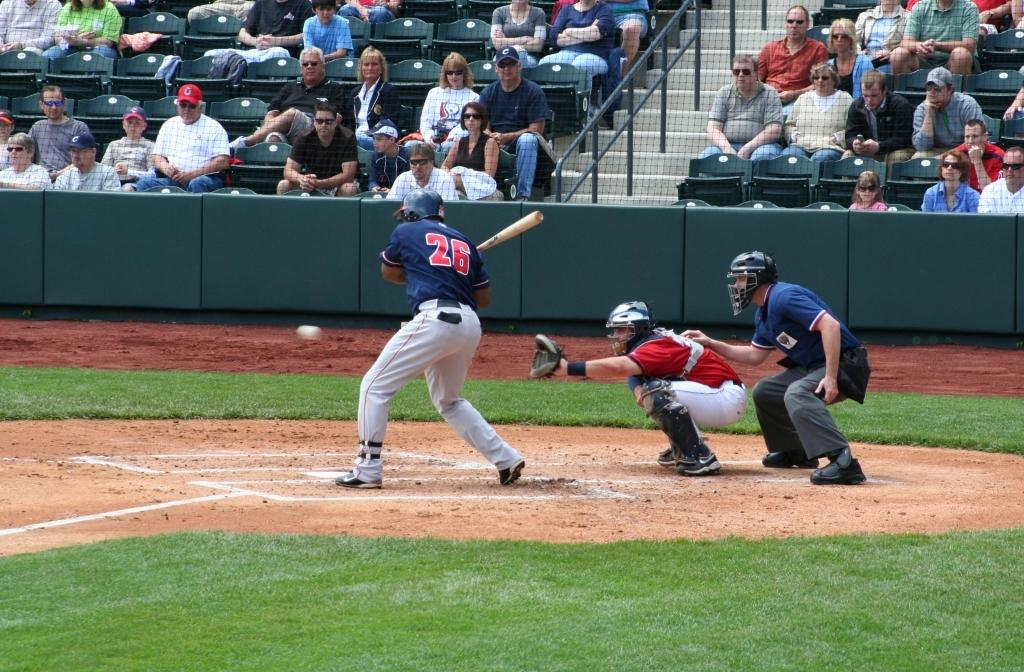<image>
Create a compact narrative representing the image presented. Player wearing number 26 getting ready to bat. 